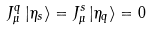<formula> <loc_0><loc_0><loc_500><loc_500>J _ { \mu } ^ { q } \left | \eta _ { s } \right > = J _ { \mu } ^ { s } \left | \eta _ { q } \right > = 0</formula> 